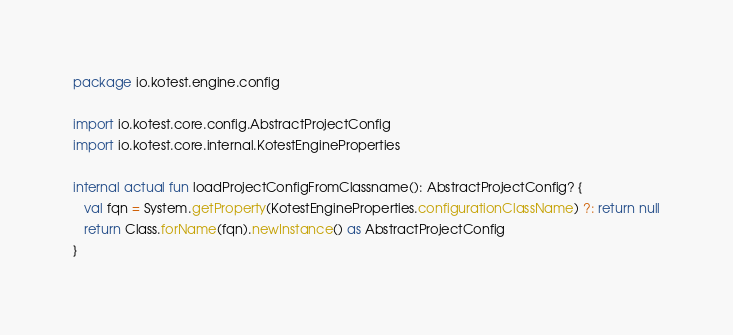<code> <loc_0><loc_0><loc_500><loc_500><_Kotlin_>package io.kotest.engine.config

import io.kotest.core.config.AbstractProjectConfig
import io.kotest.core.internal.KotestEngineProperties

internal actual fun loadProjectConfigFromClassname(): AbstractProjectConfig? {
   val fqn = System.getProperty(KotestEngineProperties.configurationClassName) ?: return null
   return Class.forName(fqn).newInstance() as AbstractProjectConfig
}
</code> 